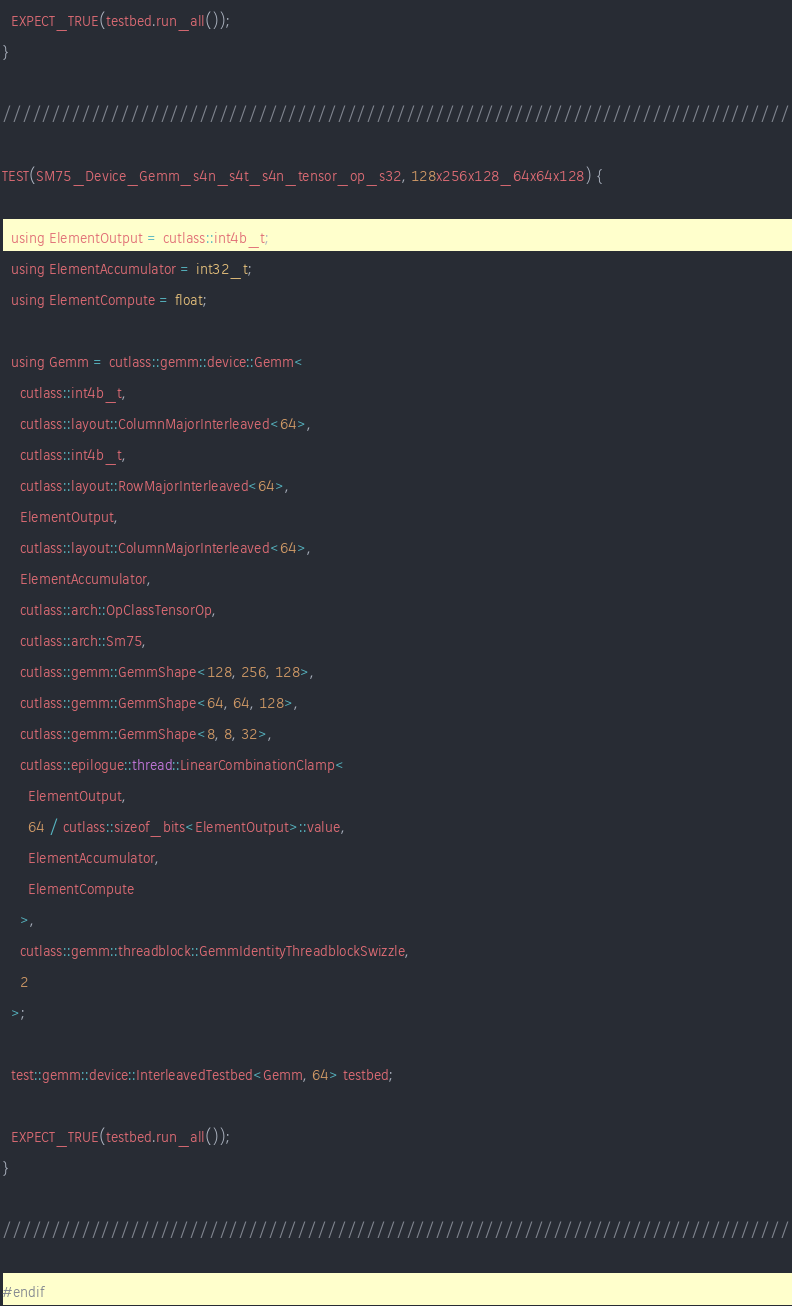<code> <loc_0><loc_0><loc_500><loc_500><_Cuda_>  EXPECT_TRUE(testbed.run_all());
}

////////////////////////////////////////////////////////////////////////////////

TEST(SM75_Device_Gemm_s4n_s4t_s4n_tensor_op_s32, 128x256x128_64x64x128) {

  using ElementOutput = cutlass::int4b_t;
  using ElementAccumulator = int32_t;
  using ElementCompute = float;

  using Gemm = cutlass::gemm::device::Gemm<
    cutlass::int4b_t,
    cutlass::layout::ColumnMajorInterleaved<64>,
    cutlass::int4b_t,
    cutlass::layout::RowMajorInterleaved<64>,
    ElementOutput,
    cutlass::layout::ColumnMajorInterleaved<64>,
    ElementAccumulator,
    cutlass::arch::OpClassTensorOp,
    cutlass::arch::Sm75,
    cutlass::gemm::GemmShape<128, 256, 128>,
    cutlass::gemm::GemmShape<64, 64, 128>,
    cutlass::gemm::GemmShape<8, 8, 32>,
    cutlass::epilogue::thread::LinearCombinationClamp<
      ElementOutput,
      64 / cutlass::sizeof_bits<ElementOutput>::value,
      ElementAccumulator,
      ElementCompute
    >,
    cutlass::gemm::threadblock::GemmIdentityThreadblockSwizzle,
    2
  >;

  test::gemm::device::InterleavedTestbed<Gemm, 64> testbed;

  EXPECT_TRUE(testbed.run_all());
}

////////////////////////////////////////////////////////////////////////////////

#endif
</code> 